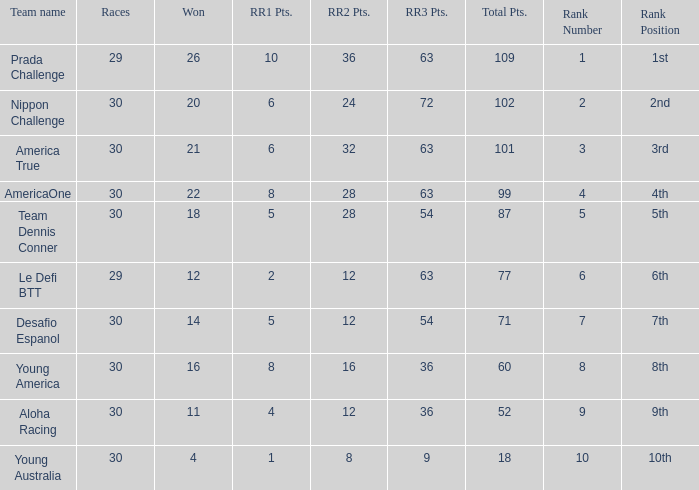Name the min total pts for team dennis conner 87.0. 